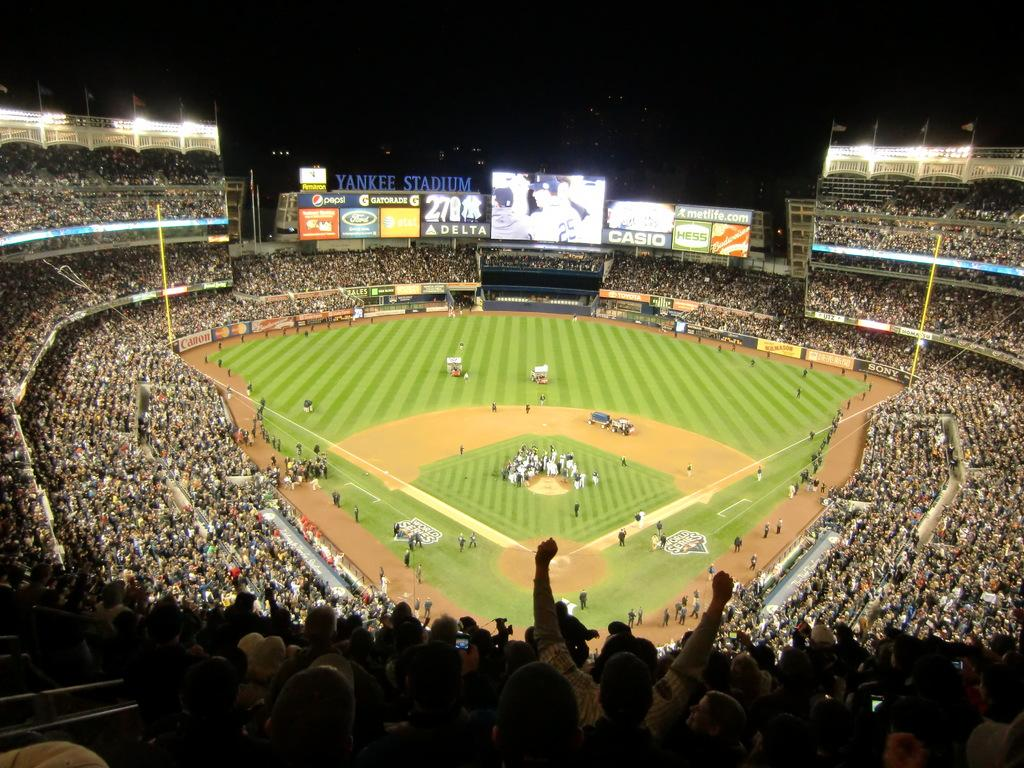<image>
Describe the image concisely. A highly attended baseball game at Yankee Stadium. 